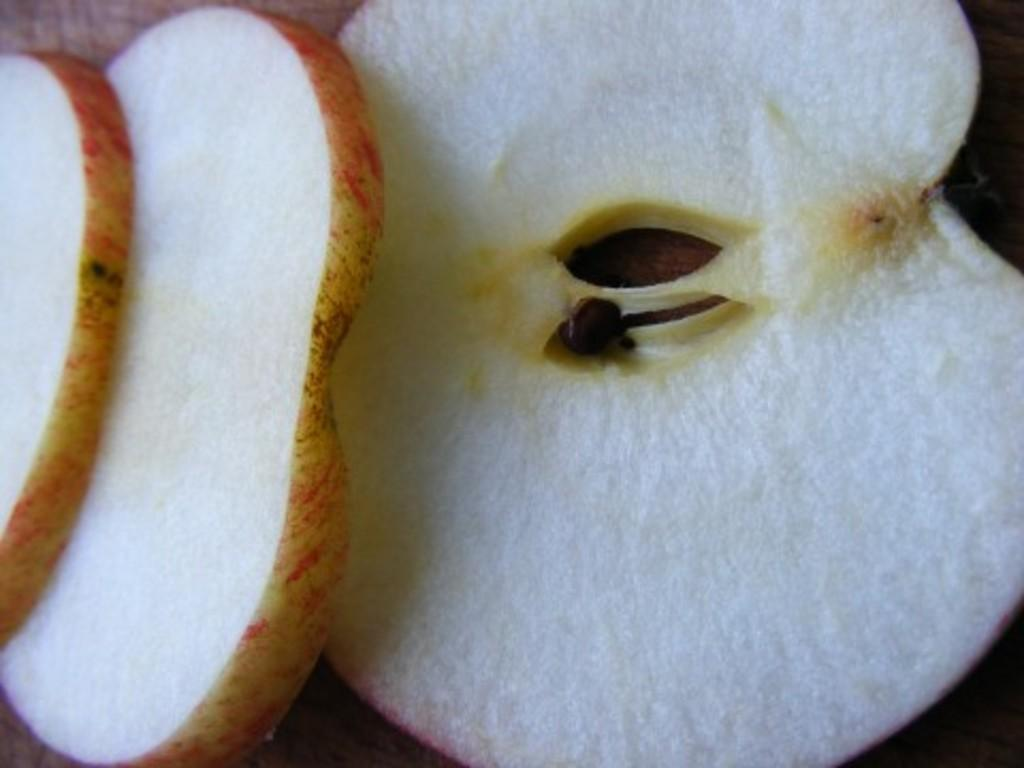What type of fruit is featured in the image? There are slices of apple in the image. What colors can be seen on the apple slices? The apple slices have white and red colors. What part of the apple is visible in the image? There is a brown color seed visible in the image. What type of story is being told in the image? There is no story being told in the image; it simply features slices of apple. Can you tell me how many potatoes are present in the image? There are no potatoes present in the image; it only features apple slices. 